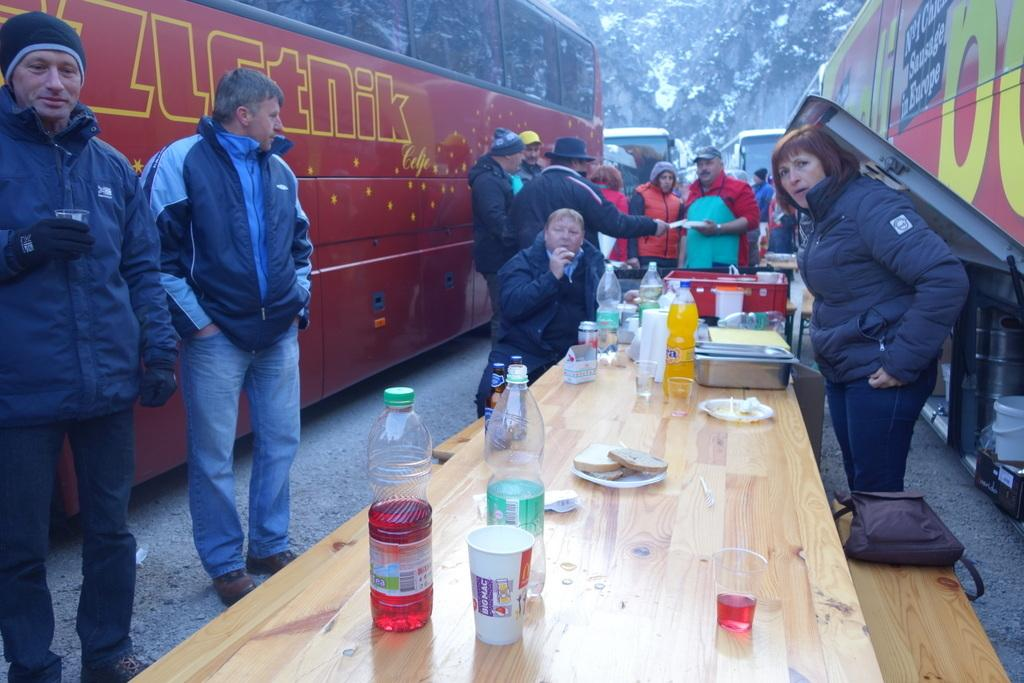What are the people near in the image? The people are standing near a table. What items can be seen on the table in the image? The table contains bottles, glasses, plates, bowls, and tins. What type of vegetation is present in the image? There are bushes and trees in the image. What type of fowl can be seen flying over the table in the image? There is no fowl present in the image; it only shows people standing near a table with various items on it, surrounded by bushes and trees. What is the elevation of the table in the image? The elevation or height of the table cannot be determined from the image alone, as there is no reference point provided for comparison. 